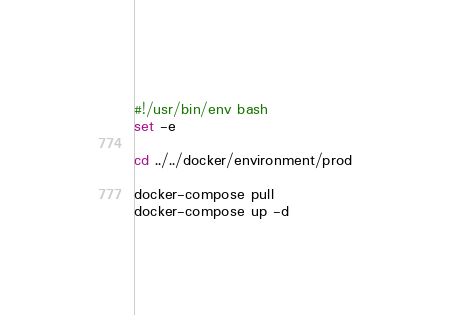<code> <loc_0><loc_0><loc_500><loc_500><_Bash_>#!/usr/bin/env bash
set -e

cd ../../docker/environment/prod

docker-compose pull
docker-compose up -d</code> 